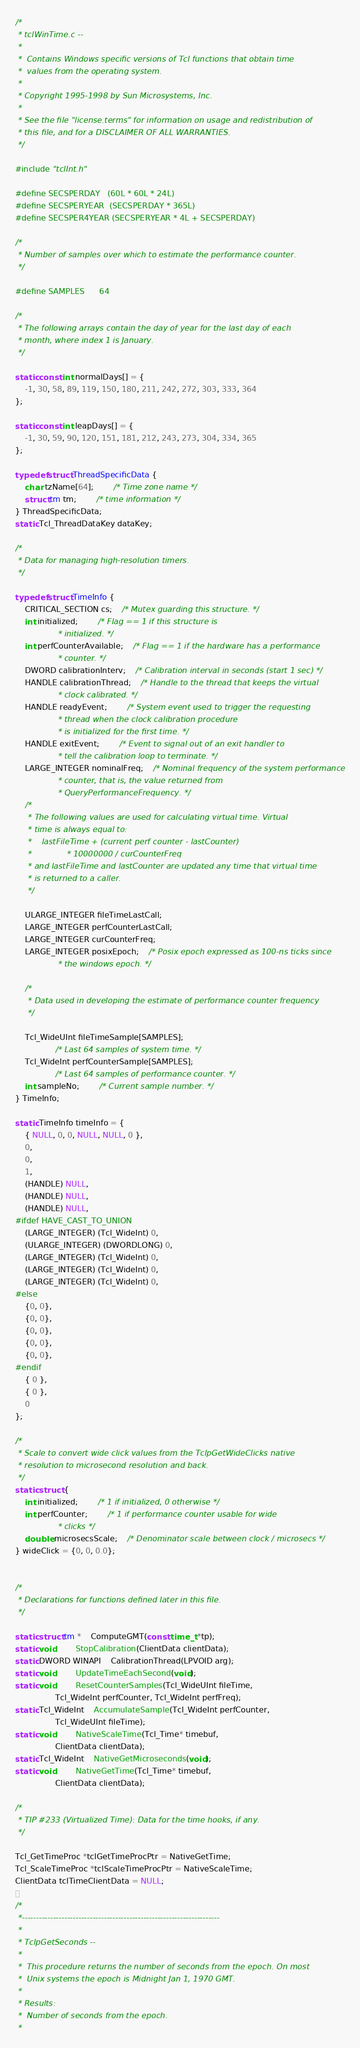Convert code to text. <code><loc_0><loc_0><loc_500><loc_500><_C_>/*
 * tclWinTime.c --
 *
 *	Contains Windows specific versions of Tcl functions that obtain time
 *	values from the operating system.
 *
 * Copyright 1995-1998 by Sun Microsystems, Inc.
 *
 * See the file "license.terms" for information on usage and redistribution of
 * this file, and for a DISCLAIMER OF ALL WARRANTIES.
 */

#include "tclInt.h"

#define SECSPERDAY	(60L * 60L * 24L)
#define SECSPERYEAR	(SECSPERDAY * 365L)
#define SECSPER4YEAR	(SECSPERYEAR * 4L + SECSPERDAY)

/*
 * Number of samples over which to estimate the performance counter.
 */

#define SAMPLES		64

/*
 * The following arrays contain the day of year for the last day of each
 * month, where index 1 is January.
 */

static const int normalDays[] = {
    -1, 30, 58, 89, 119, 150, 180, 211, 242, 272, 303, 333, 364
};

static const int leapDays[] = {
    -1, 30, 59, 90, 120, 151, 181, 212, 243, 273, 304, 334, 365
};

typedef struct ThreadSpecificData {
    char tzName[64];		/* Time zone name */
    struct tm tm;		/* time information */
} ThreadSpecificData;
static Tcl_ThreadDataKey dataKey;

/*
 * Data for managing high-resolution timers.
 */

typedef struct TimeInfo {
    CRITICAL_SECTION cs;	/* Mutex guarding this structure. */
    int initialized;		/* Flag == 1 if this structure is
				 * initialized. */
    int perfCounterAvailable;	/* Flag == 1 if the hardware has a performance
				 * counter. */
    DWORD calibrationInterv;	/* Calibration interval in seconds (start 1 sec) */
    HANDLE calibrationThread;	/* Handle to the thread that keeps the virtual
				 * clock calibrated. */
    HANDLE readyEvent;		/* System event used to trigger the requesting
				 * thread when the clock calibration procedure
				 * is initialized for the first time. */
    HANDLE exitEvent; 		/* Event to signal out of an exit handler to
				 * tell the calibration loop to terminate. */
    LARGE_INTEGER nominalFreq;	/* Nominal frequency of the system performance
				 * counter, that is, the value returned from
				 * QueryPerformanceFrequency. */
    /*
     * The following values are used for calculating virtual time. Virtual
     * time is always equal to:
     *    lastFileTime + (current perf counter - lastCounter)
     *				* 10000000 / curCounterFreq
     * and lastFileTime and lastCounter are updated any time that virtual time
     * is returned to a caller.
     */

    ULARGE_INTEGER fileTimeLastCall;
    LARGE_INTEGER perfCounterLastCall;
    LARGE_INTEGER curCounterFreq;
    LARGE_INTEGER posixEpoch;	/* Posix epoch expressed as 100-ns ticks since
				 * the windows epoch. */

    /*
     * Data used in developing the estimate of performance counter frequency
     */

    Tcl_WideUInt fileTimeSample[SAMPLES];
				/* Last 64 samples of system time. */
    Tcl_WideInt perfCounterSample[SAMPLES];
				/* Last 64 samples of performance counter. */
    int sampleNo;		/* Current sample number. */
} TimeInfo;

static TimeInfo timeInfo = {
    { NULL, 0, 0, NULL, NULL, 0 },
    0,
    0,
    1,
    (HANDLE) NULL,
    (HANDLE) NULL,
    (HANDLE) NULL,
#ifdef HAVE_CAST_TO_UNION
    (LARGE_INTEGER) (Tcl_WideInt) 0,
    (ULARGE_INTEGER) (DWORDLONG) 0,
    (LARGE_INTEGER) (Tcl_WideInt) 0,
    (LARGE_INTEGER) (Tcl_WideInt) 0,
    (LARGE_INTEGER) (Tcl_WideInt) 0,
#else
    {0, 0},
    {0, 0},
    {0, 0},
    {0, 0},
    {0, 0},
#endif
    { 0 },
    { 0 },
    0
};

/*
 * Scale to convert wide click values from the TclpGetWideClicks native
 * resolution to microsecond resolution and back.
 */
static struct {
    int initialized;		/* 1 if initialized, 0 otherwise */
    int perfCounter;		/* 1 if performance counter usable for wide
				 * clicks */
    double microsecsScale;	/* Denominator scale between clock / microsecs */
} wideClick = {0, 0, 0.0};


/*
 * Declarations for functions defined later in this file.
 */

static struct tm *	ComputeGMT(const time_t *tp);
static void		StopCalibration(ClientData clientData);
static DWORD WINAPI	CalibrationThread(LPVOID arg);
static void 		UpdateTimeEachSecond(void);
static void		ResetCounterSamples(Tcl_WideUInt fileTime,
			    Tcl_WideInt perfCounter, Tcl_WideInt perfFreq);
static Tcl_WideInt	AccumulateSample(Tcl_WideInt perfCounter,
			    Tcl_WideUInt fileTime);
static void		NativeScaleTime(Tcl_Time* timebuf,
			    ClientData clientData);
static Tcl_WideInt	NativeGetMicroseconds(void);
static void		NativeGetTime(Tcl_Time* timebuf,
			    ClientData clientData);

/*
 * TIP #233 (Virtualized Time): Data for the time hooks, if any.
 */

Tcl_GetTimeProc *tclGetTimeProcPtr = NativeGetTime;
Tcl_ScaleTimeProc *tclScaleTimeProcPtr = NativeScaleTime;
ClientData tclTimeClientData = NULL;

/*
 *----------------------------------------------------------------------
 *
 * TclpGetSeconds --
 *
 *	This procedure returns the number of seconds from the epoch. On most
 *	Unix systems the epoch is Midnight Jan 1, 1970 GMT.
 *
 * Results:
 *	Number of seconds from the epoch.
 *</code> 